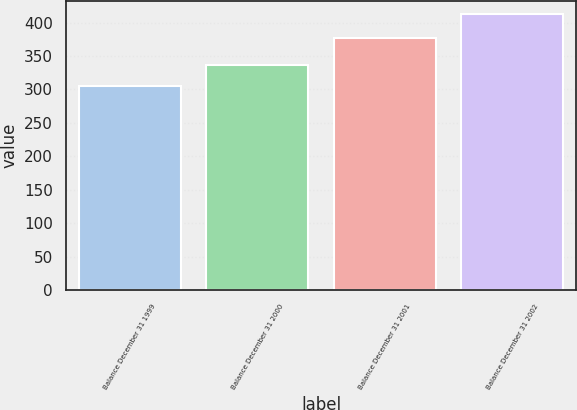<chart> <loc_0><loc_0><loc_500><loc_500><bar_chart><fcel>Balance December 31 1999<fcel>Balance December 31 2000<fcel>Balance December 31 2001<fcel>Balance December 31 2002<nl><fcel>304.5<fcel>336.5<fcel>376.7<fcel>412<nl></chart> 